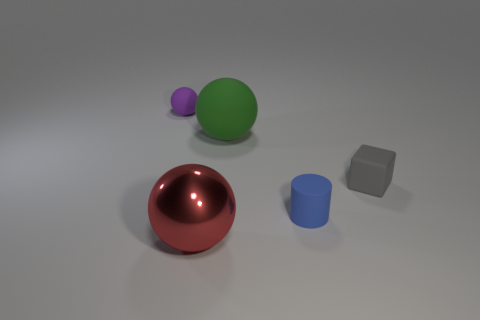There is a gray thing that is the same size as the blue rubber cylinder; what is its material? The gray object appears to have a matte surface suggesting it could be made of a dull plastic or possibly ceramic. It does not exhibit the shininess typically associated with metal or the translucence of glass. 